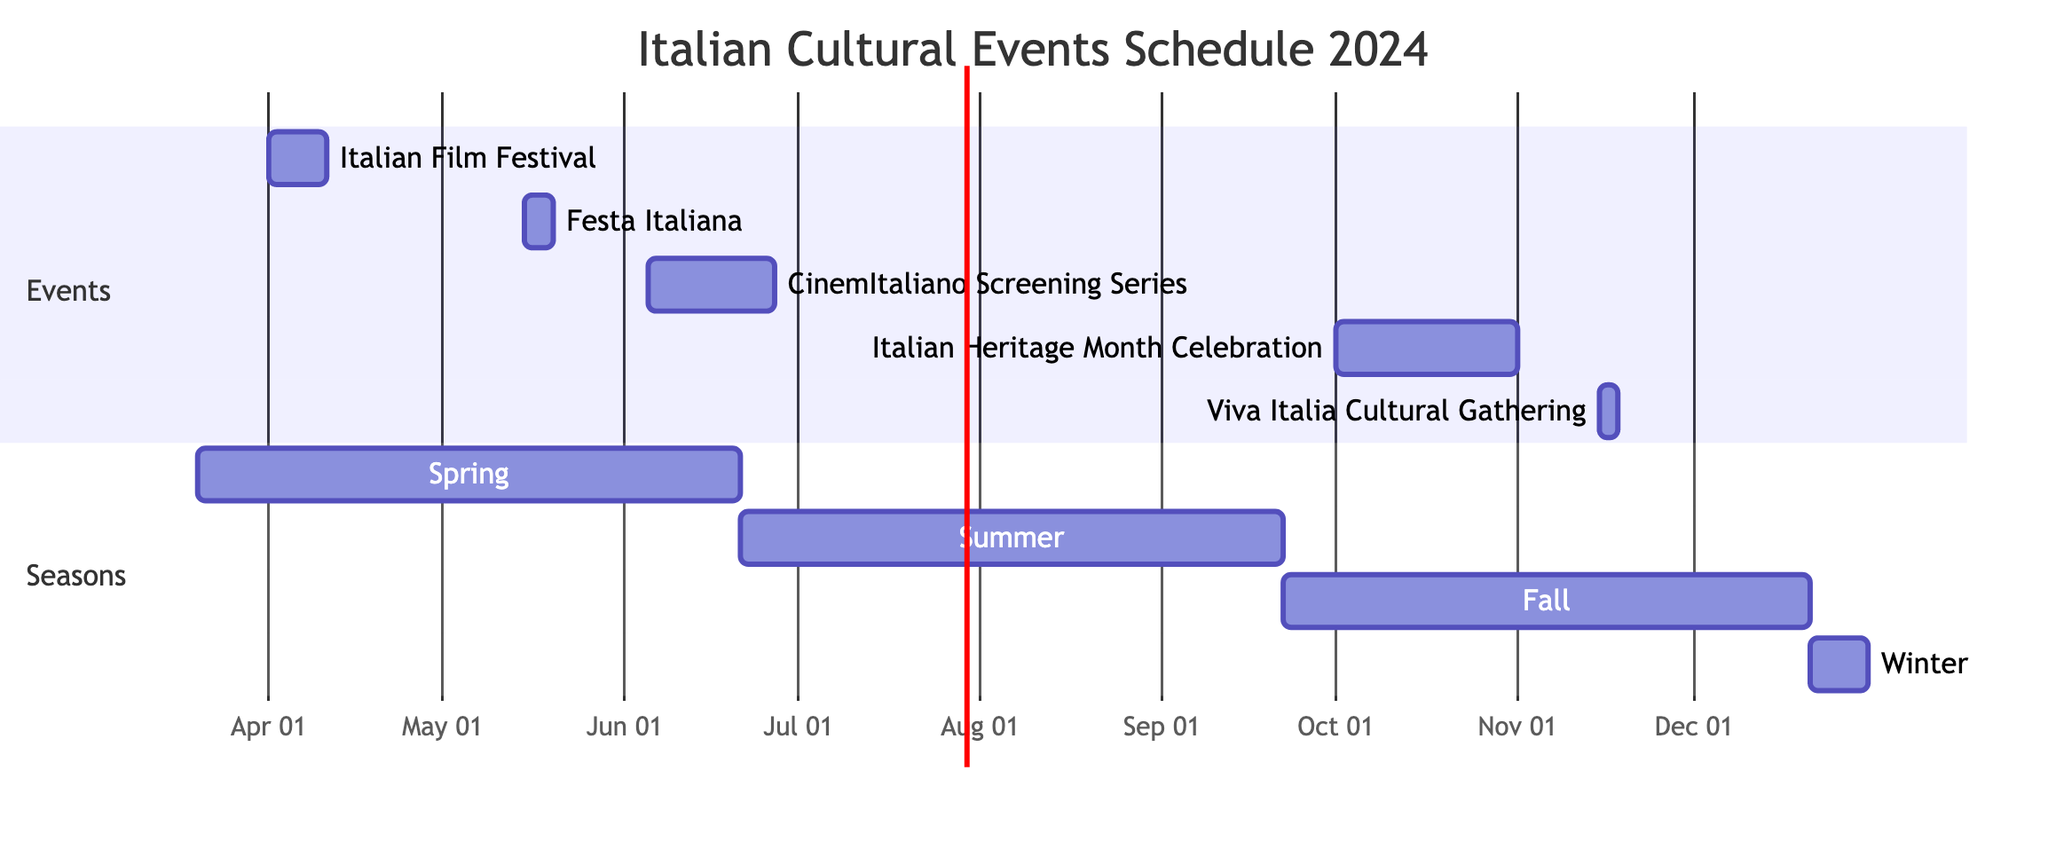What is the duration of the Italian Film Festival? The Italian Film Festival starts on April 1, 2024, and ends on April 10, 2024. This gives it a duration of 10 days.
Answer: 10 days Which event occurs first in the schedule? The events are listed by their start dates. The Italian Film Festival starts on April 1, 2024, which is before any other event.
Answer: Italian Film Festival How many events are scheduled in the month of May? There is one event, the Festa Italiana, which runs from May 15 to May 19. By counting the events falling in that month, we find only one.
Answer: 1 What is the last event of the year? By examining the end dates of each event, the last event is the Italian Heritage Month Celebration, which ends on October 31, 2024.
Answer: Italian Heritage Month Celebration How many days does the CinemItaliano Screening Series last? The CinemItaliano Screening Series starts on June 5, 2024, and ends on June 26, 2024. The total duration is 22 days (from start to end inclusive).
Answer: 22 days Which season does the Viva Italia Cultural Gathering fall into? The Viva Italia Cultural Gathering is scheduled for November 15-17, 2024, which falls within the Fall season (September 22 to December 21).
Answer: Fall How many total events are scheduled in the year 2024? Counting each event listed in the schedule, there are a total of five distinct events planned for the year.
Answer: 5 What are the dates for the Festa Italiana? The Festa Italiana runs from May 15, 2024, to May 19, 2024, constituting the specific dates for this event.
Answer: May 15 to May 19, 2024 